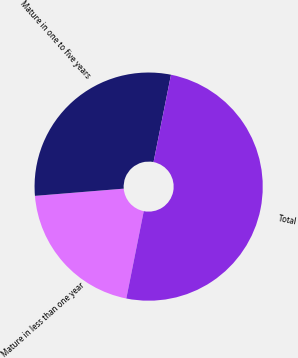Convert chart. <chart><loc_0><loc_0><loc_500><loc_500><pie_chart><fcel>Mature in less than one year<fcel>Mature in one to five years<fcel>Total<nl><fcel>20.57%<fcel>29.43%<fcel>50.0%<nl></chart> 